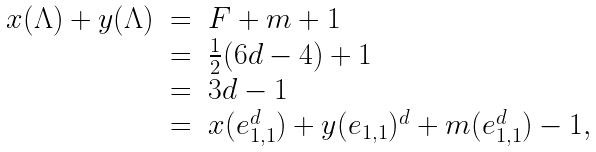Convert formula to latex. <formula><loc_0><loc_0><loc_500><loc_500>\begin{array} { l c l } x ( \Lambda ) + y ( \Lambda ) & = & F + m + 1 \\ & = & \frac { 1 } { 2 } ( 6 d - 4 ) + 1 \\ & = & 3 d - 1 \\ & = & x ( e _ { 1 , 1 } ^ { d } ) + y ( e _ { 1 , 1 } ) ^ { d } + m ( e _ { 1 , 1 } ^ { d } ) - 1 , \\ \end{array}</formula> 